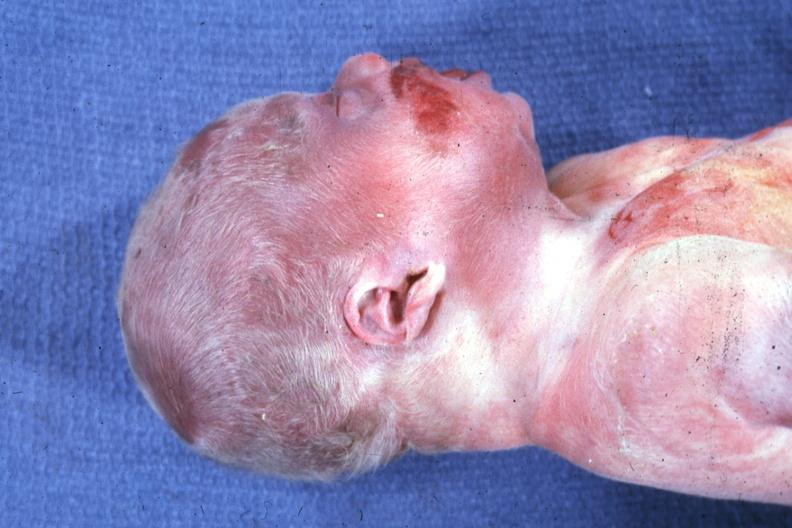what does this image show?
Answer the question using a single word or phrase. Lateral view of head with ear lobe crease and web neck other photos in file are anterior face whole body showing diastasis recti and kidneys with bilateral pelvic-ureteral strictures 